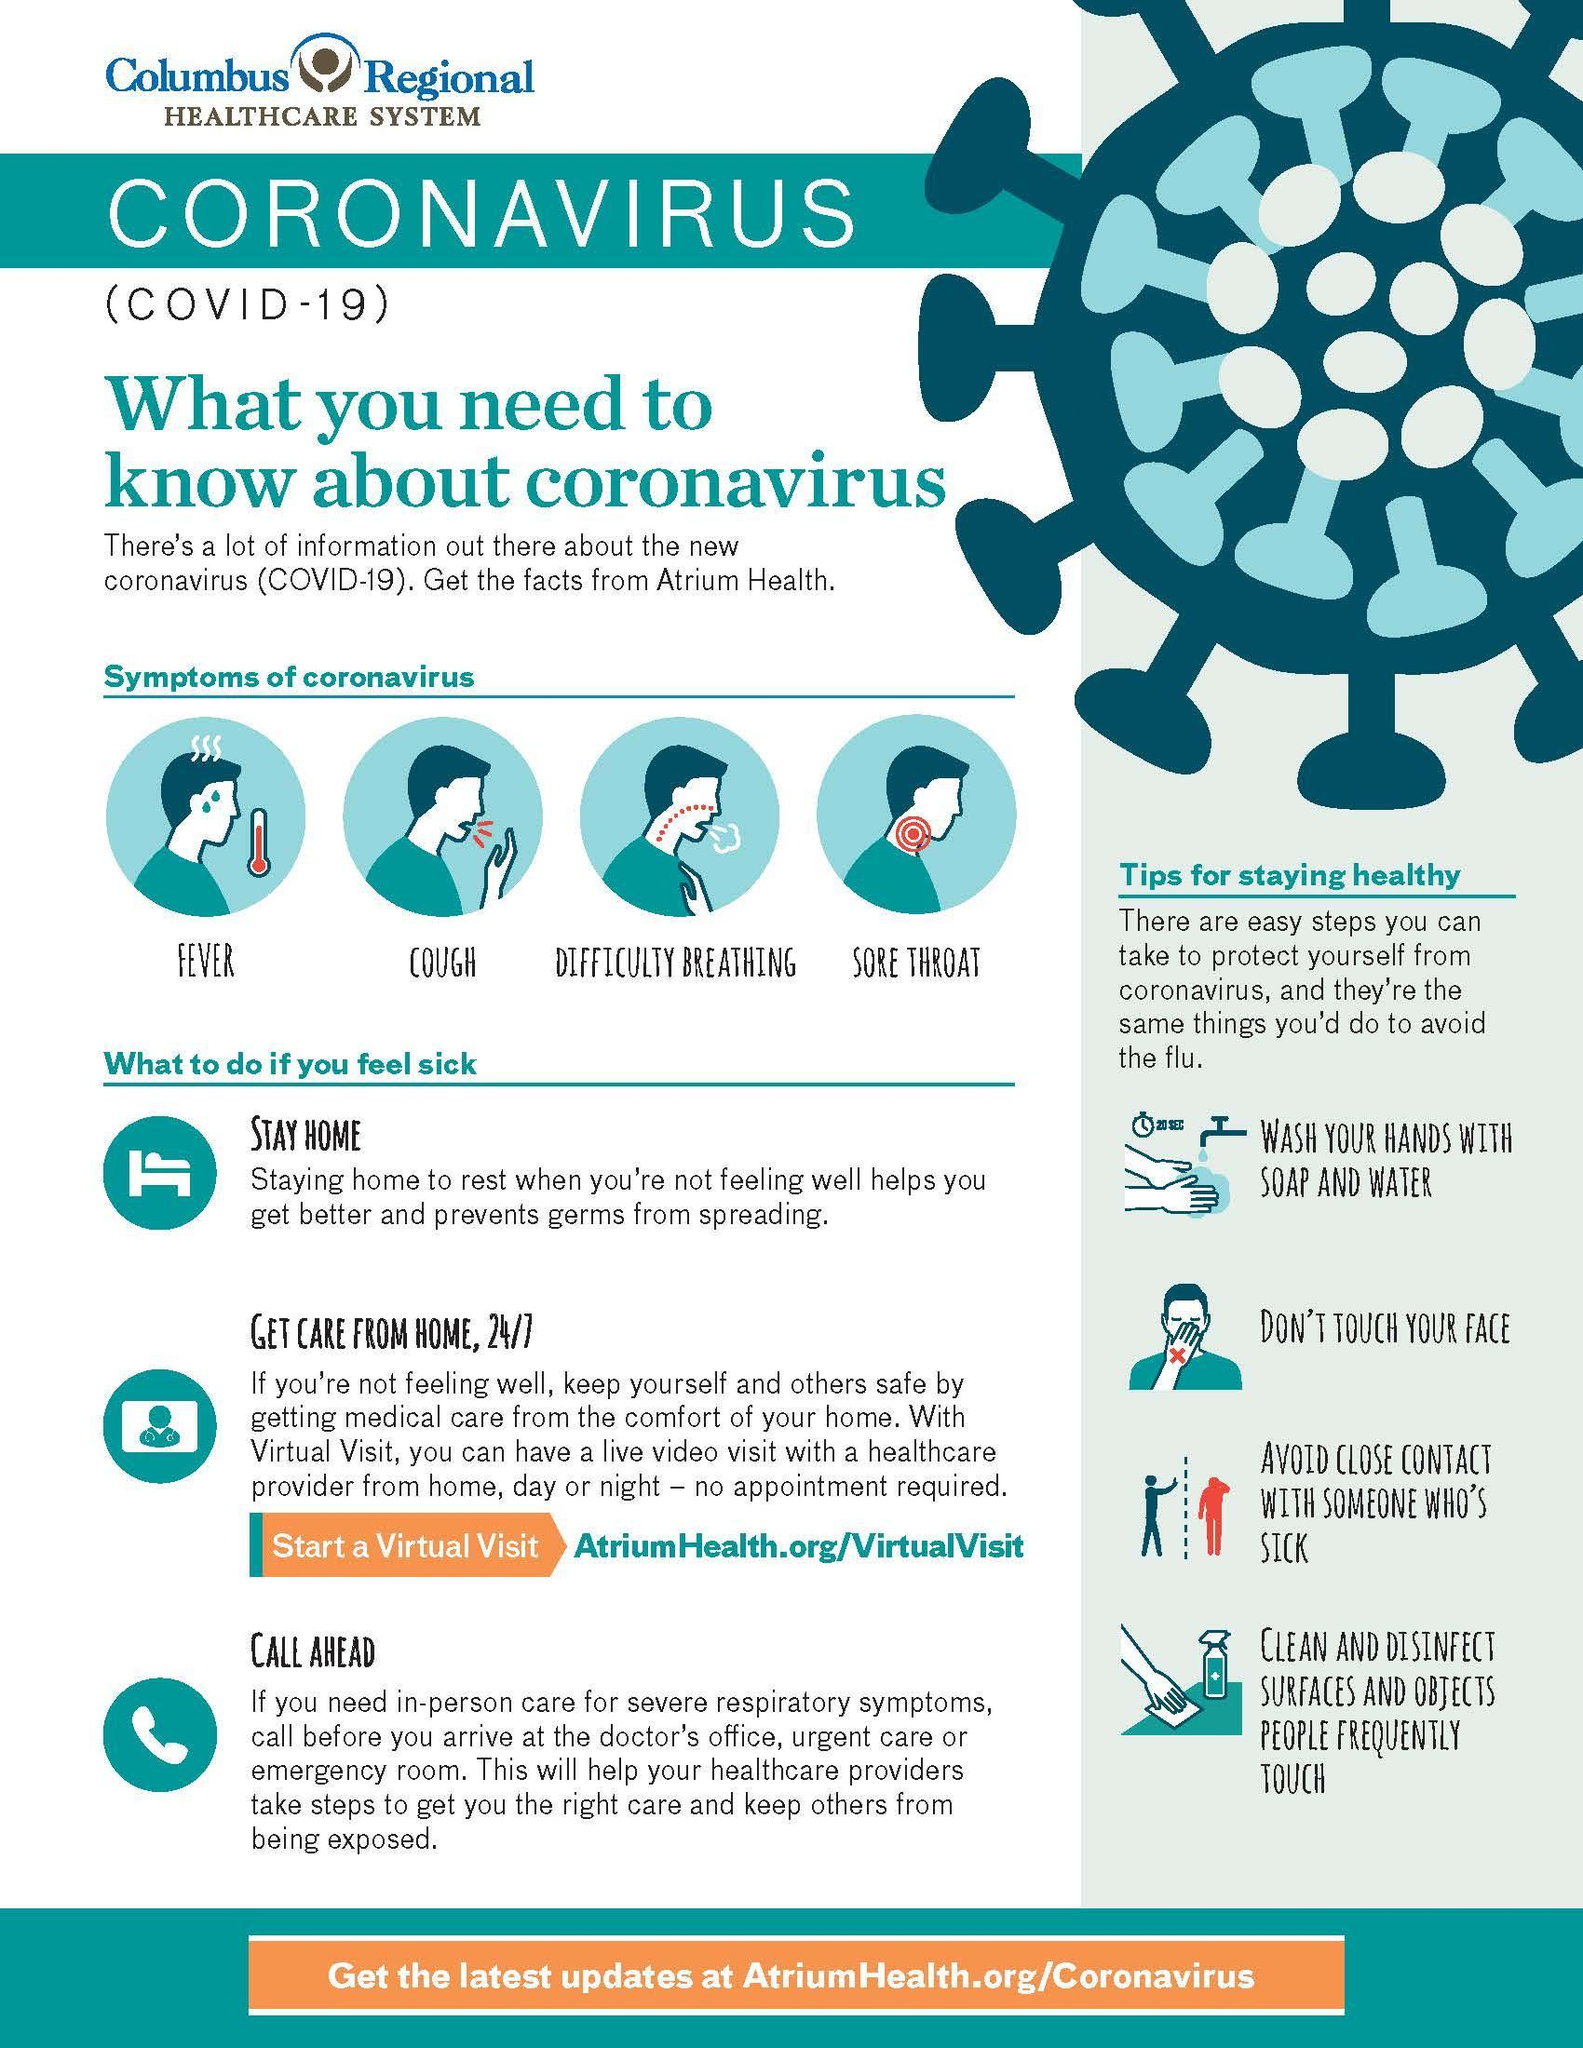How many tips to stay healthy are mentioned in the infographic?
Answer the question with a short phrase. 4 What should be cleaned and disinfected? surfaces and objects people frequently touch What is the fourth symptom of coronavirus shown in the infographic? sore throat What is the second symptom of coronavirus shown in the infographic? cough For how long should hands be washed with soap and water? 20 sec What is listed second in the tips to stay healthy? don't touch your face How many symptoms of coronavirus are shown in the infographic? 4 